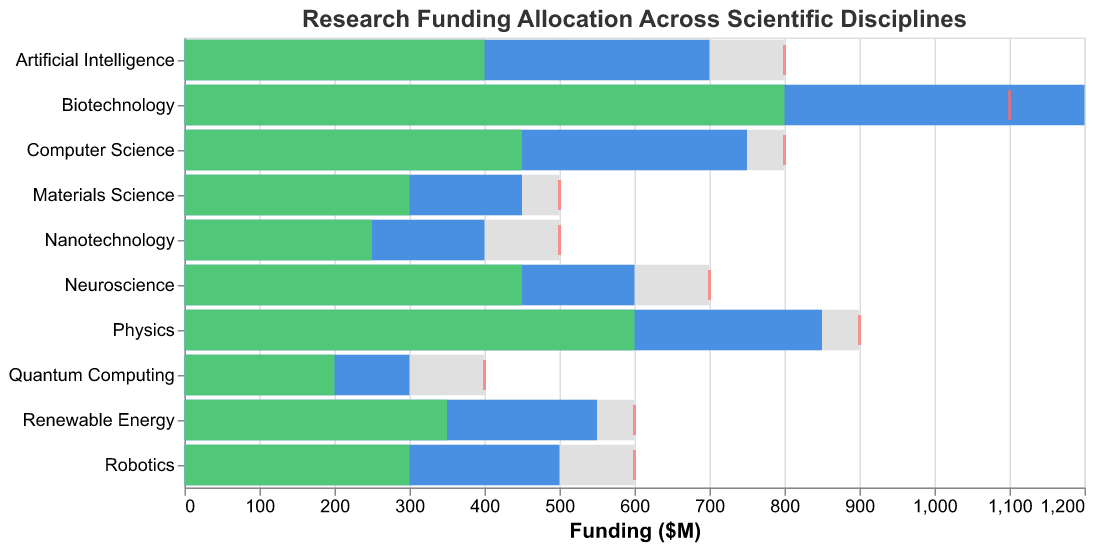What is the title of the chart? The title is located at the top of the chart and typically describes the main topic or purpose of the chart.
Answer: Research Funding Allocation Across Scientific Disciplines How many scientific disciplines are displayed in the chart? Count the number of rows, each representing a different scientific discipline.
Answer: 10 Which discipline received the highest total funding? Look for the bar that extends the furthest along the x-axis.
Answer: Biotechnology Which discipline has the lowest total funding? Look for the bar that extends the least distance along the x-axis.
Answer: Quantum Computing How much federal funding did Artificial Intelligence receive? Look for the specific section of the bar for Artificial Intelligence representing federal funding.
Answer: 400 million dollars Did any discipline meet or exceed its funding target? Compare the length of each bar to the respective tick mark on the x-axis representing the funding target.
Answer: No discipline met or exceeded its target Which discipline has the largest difference between total funding and its target funding? Calculate the difference between the total funding and target funding for each discipline and identify the largest gap.
Answer: Biotechnology (1200 - 1100 = 100 million dollars) How much funding does Neuroscience receive from non-profit sources? Look for the specific section of the bar for Neuroscience representing funding from non-profit sources.
Answer: 50 million dollars Which discipline comes closest to meeting its funding target? Find the discipline where the total funding is nearest to its target funding without exceeding it.
Answer: Physics (850 out of 900 million dollars) Compare the federal funding for Computer Science and Robotics. Which one received more? Look at the specific sections of the bars for Computer Science and Robotics representing federal funding and compare their lengths.
Answer: Computer Science (450 million dollars) What is the total funding from industry sources for all disciplines combined? Sum the industry funding amounts for all disciplines: 150 (Physics) + 250 (Computer Science) + 300 (Biotechnology) + 150 (Robotics) + 100 (Neuroscience) + 100 (Nanotechnology) + 250 (Artificial Intelligence) + 75 (Quantum Computing) + 100 (Materials Science) + 150 (Renewable Energy) = 1625 million dollars.
Answer: 1625 million dollars 